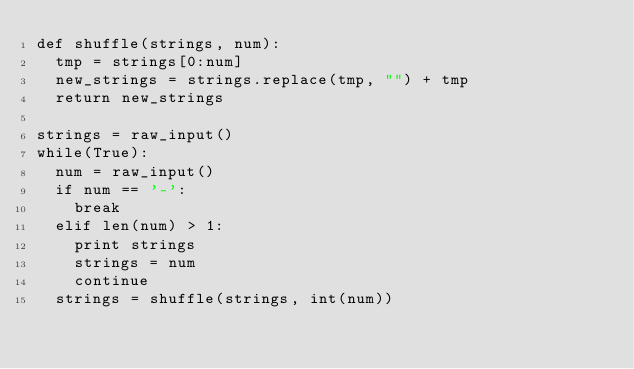<code> <loc_0><loc_0><loc_500><loc_500><_Python_>def shuffle(strings, num):
  tmp = strings[0:num]
  new_strings = strings.replace(tmp, "") + tmp
  return new_strings

strings = raw_input()
while(True):
  num = raw_input()
  if num == '-':
    break
  elif len(num) > 1:
    print strings
    strings = num
    continue
  strings = shuffle(strings, int(num))</code> 